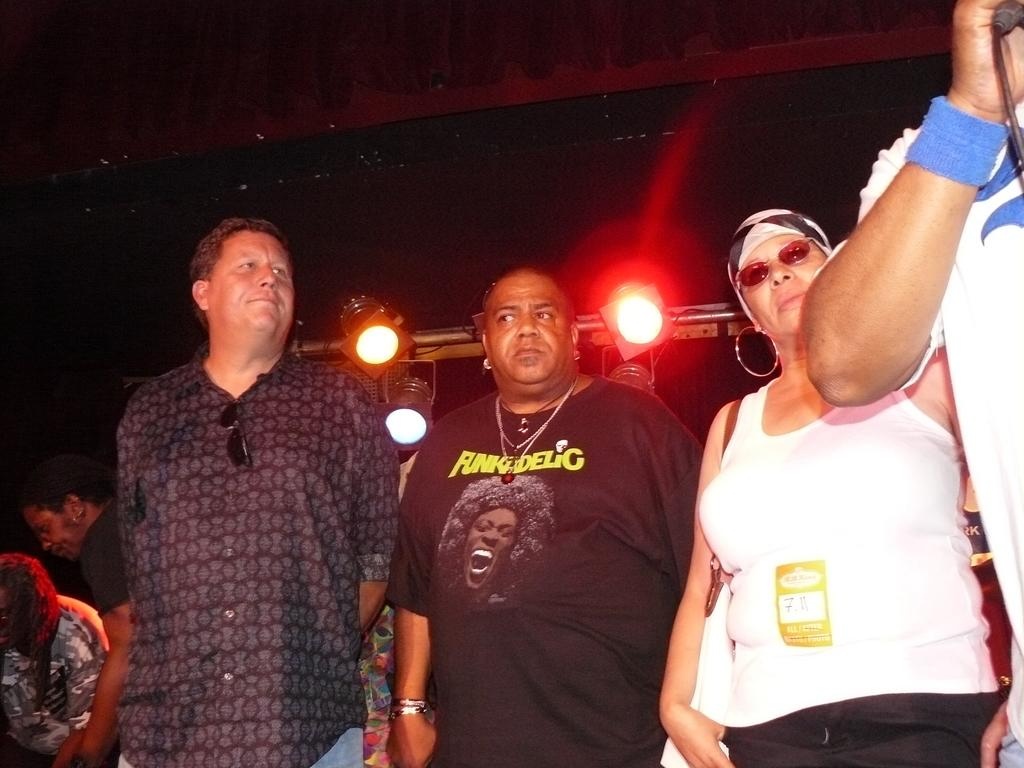What is happening in the image? There is a group of persons standing in the image. Where are the persons located in the image? The group of persons is at the bottom of the image. What can be seen in the middle of the image? There are lights in the middle of the image. What is the color of the background in the image? The background of the image is dark. What type of slave is depicted in the image? There is no slave depicted in the image; it features a group of persons standing. What type of maid is present in the image? There is no maid present in the image. 